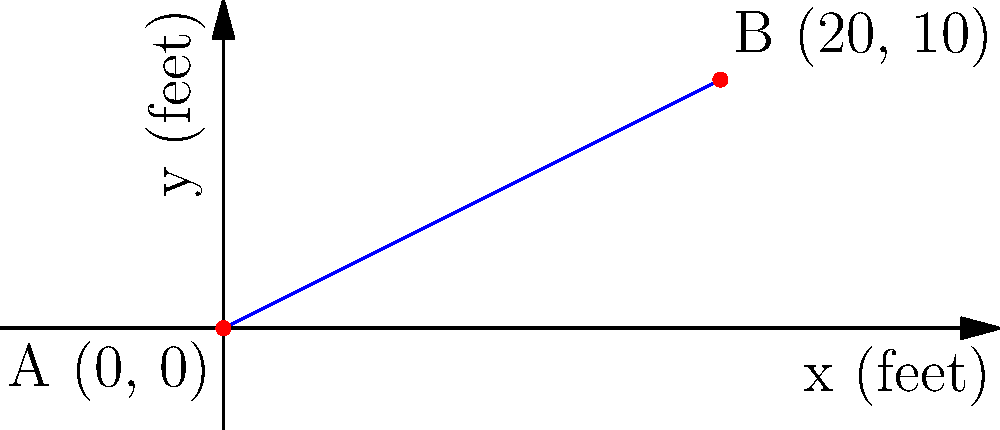As a seasoned basketball player, you're analyzing shooting trajectories. The graph shows the path of a basketball shot, with point A representing the release point and point B the basket. Given that the horizontal distance between A and B is 20 feet and the vertical distance is 10 feet, calculate the slope of the line representing the ball's trajectory. How does this slope relate to the shot's angle? To solve this problem, we'll follow these steps:

1) Recall the slope formula: $m = \frac{y_2 - y_1}{x_2 - x_1}$

2) Identify the coordinates:
   Point A: $(x_1, y_1) = (0, 0)$
   Point B: $(x_2, y_2) = (20, 10)$

3) Plug these values into the slope formula:

   $m = \frac{10 - 0}{20 - 0} = \frac{10}{20}$

4) Simplify:

   $m = \frac{1}{2} = 0.5$

5) Interpret the result:
   - The slope is positive, indicating an upward trajectory.
   - A slope of 0.5 means that for every 1 unit the ball moves horizontally, it rises 0.5 units vertically.

6) Relate to the shot's angle:
   - The slope (m) is related to the angle (θ) of the shot by the formula: $m = \tan(\theta)$
   - Therefore, $\theta = \arctan(0.5) \approx 26.57°$

This angle represents the launch angle of the shot relative to the horizontal plane.
Answer: Slope = 0.5; Shot angle ≈ 26.57° 